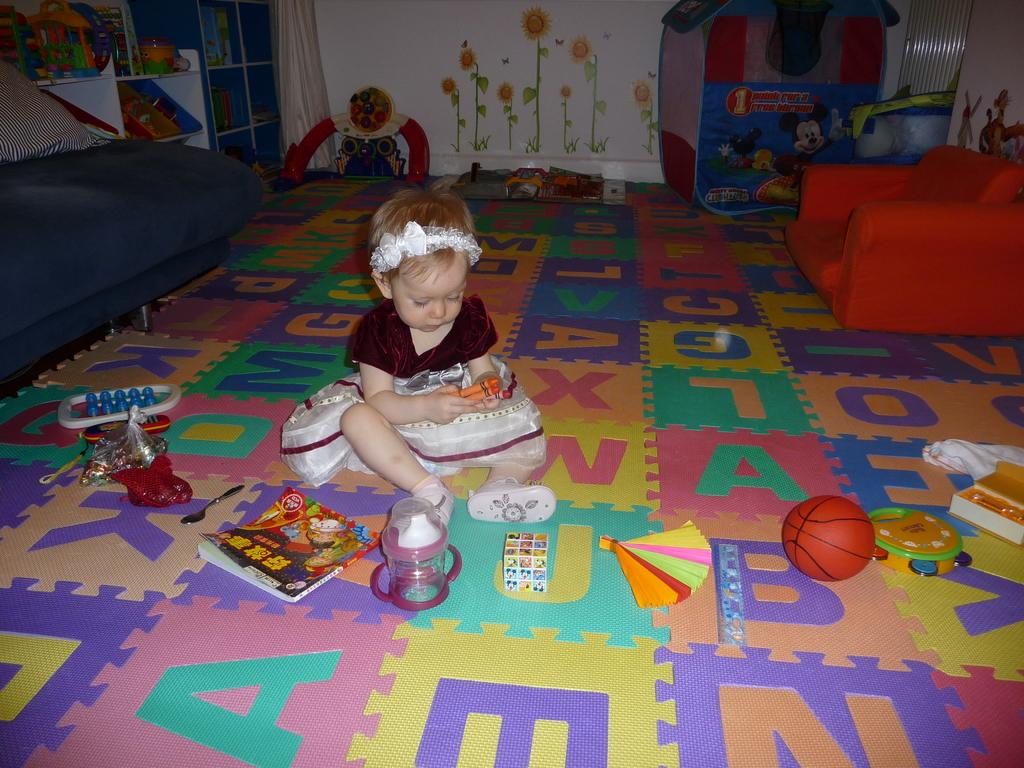Who is the main subject in the image? There is a girl in the image. What is the girl doing in the image? The girl is sitting on the floor. What other objects can be seen in the image? There are toys, a book, and a ball in the image. What is the condition of the girl's relationship with the ball in the image? There is no information about the girl's relationship with the ball in the image, as it only shows her sitting on the floor with toys, a book, and a ball nearby. 